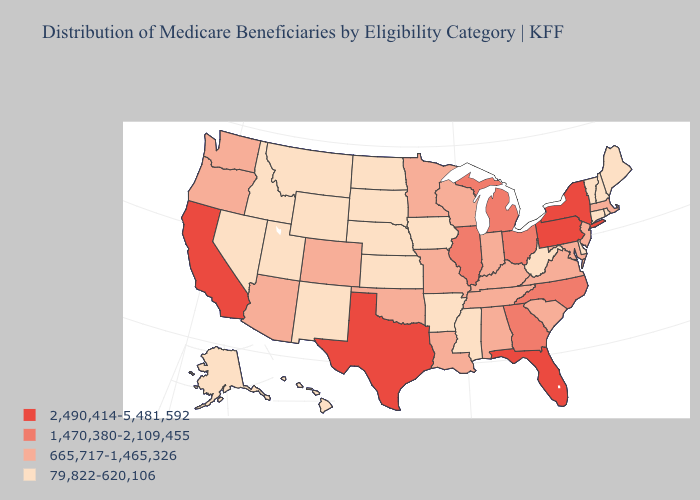What is the lowest value in states that border Missouri?
Concise answer only. 79,822-620,106. Name the states that have a value in the range 1,470,380-2,109,455?
Short answer required. Georgia, Illinois, Michigan, North Carolina, Ohio. Does Virginia have the lowest value in the USA?
Quick response, please. No. Does the map have missing data?
Quick response, please. No. What is the value of Utah?
Short answer required. 79,822-620,106. What is the highest value in the USA?
Be succinct. 2,490,414-5,481,592. Name the states that have a value in the range 665,717-1,465,326?
Concise answer only. Alabama, Arizona, Colorado, Indiana, Kentucky, Louisiana, Maryland, Massachusetts, Minnesota, Missouri, New Jersey, Oklahoma, Oregon, South Carolina, Tennessee, Virginia, Washington, Wisconsin. Which states have the highest value in the USA?
Short answer required. California, Florida, New York, Pennsylvania, Texas. Name the states that have a value in the range 2,490,414-5,481,592?
Short answer required. California, Florida, New York, Pennsylvania, Texas. What is the value of Wyoming?
Give a very brief answer. 79,822-620,106. What is the value of North Carolina?
Be succinct. 1,470,380-2,109,455. What is the value of Louisiana?
Concise answer only. 665,717-1,465,326. Which states have the lowest value in the USA?
Be succinct. Alaska, Arkansas, Connecticut, Delaware, Hawaii, Idaho, Iowa, Kansas, Maine, Mississippi, Montana, Nebraska, Nevada, New Hampshire, New Mexico, North Dakota, Rhode Island, South Dakota, Utah, Vermont, West Virginia, Wyoming. What is the value of Minnesota?
Be succinct. 665,717-1,465,326. How many symbols are there in the legend?
Write a very short answer. 4. 